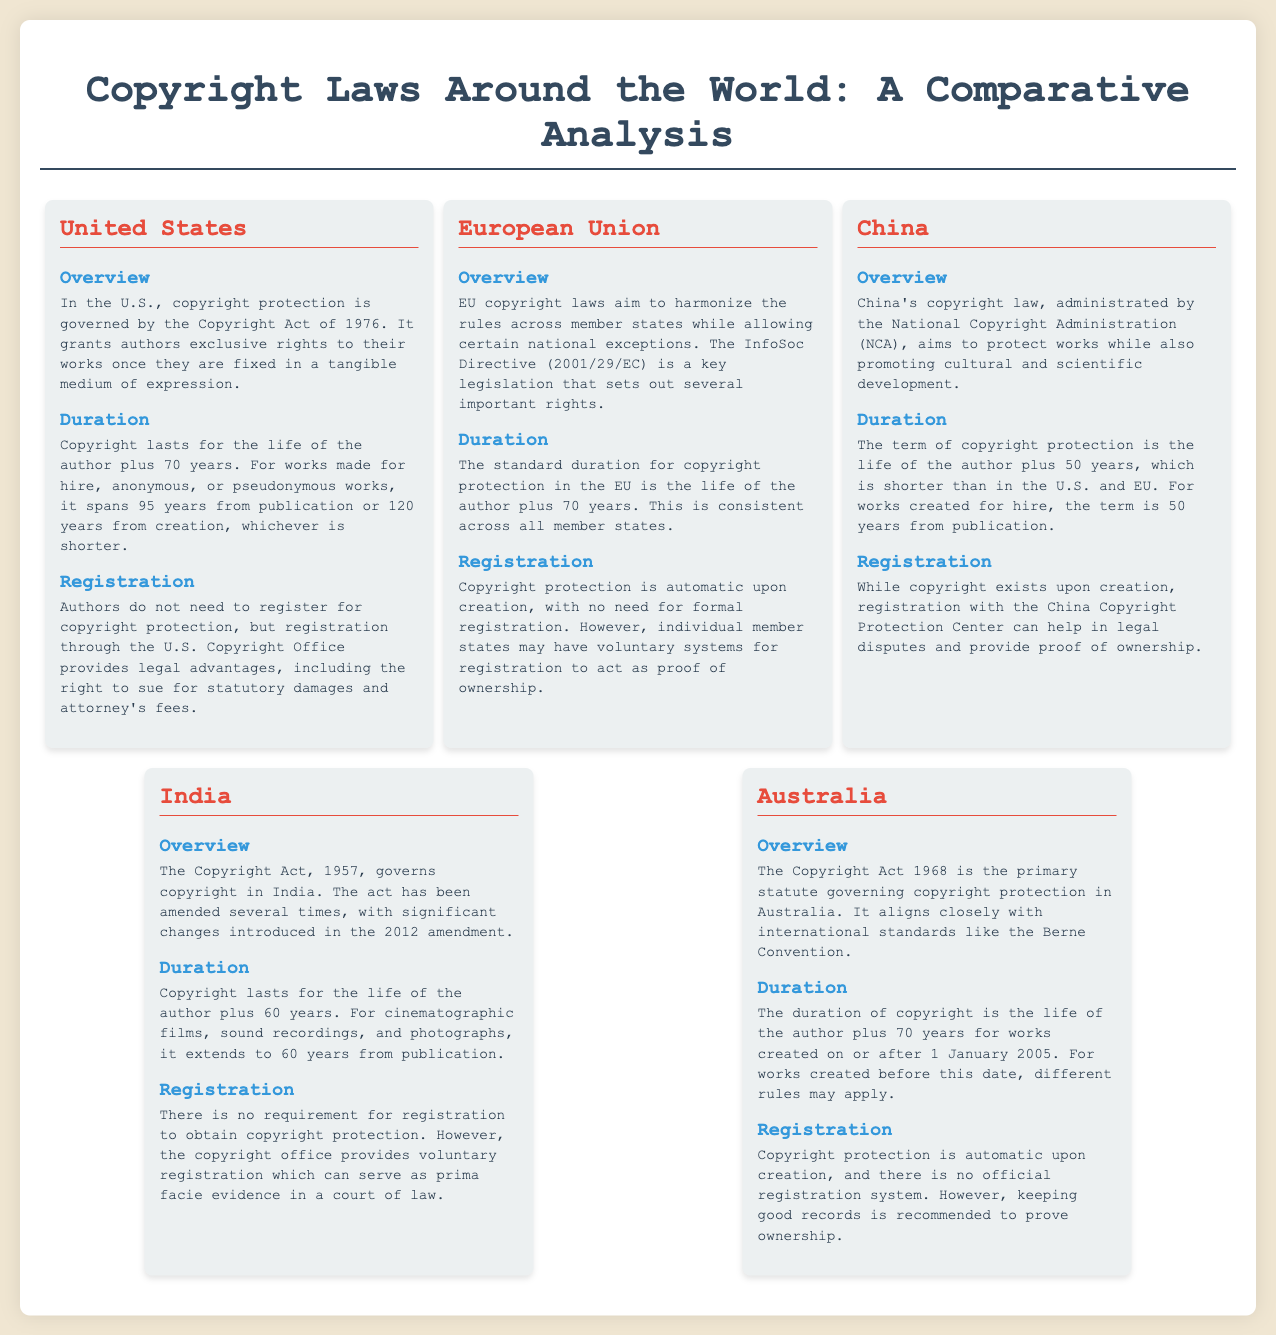what is the copyright duration in the United States? The copyright duration in the United States lasts for the life of the author plus 70 years.
Answer: life of the author plus 70 years what is the automatic copyright protection duration in the European Union? In the European Union, the standard duration for copyright protection is the life of the author plus 70 years.
Answer: life of the author plus 70 years which act governs copyright in India? The act that governs copyright in India is the Copyright Act, 1957.
Answer: Copyright Act, 1957 how long is the copyright protection in China for works made for hire? For works created for hire in China, the term of copyright protection is 50 years from publication.
Answer: 50 years from publication does Australia have an official registration system for copyright protection? No, Australia does not have an official registration system for copyright protection.
Answer: No which directive is essential for copyright in the European Union? The InfoSoc Directive (2001/29/EC) is a key legislation for copyright in the EU.
Answer: InfoSoc Directive (2001/29/EC) what is the voluntary registration system in India used for? The voluntary registration system in India can serve as prima facie evidence in a court of law.
Answer: prima facie evidence how long does copyright last for cinematographic films in India? In India, copyright for cinematographic films lasts for 60 years from publication.
Answer: 60 years from publication what is a legal advantage of registering copyright in the United States? Registration through the U.S. Copyright Office provides the right to sue for statutory damages and attorney's fees.
Answer: sue for statutory damages and attorney's fees 